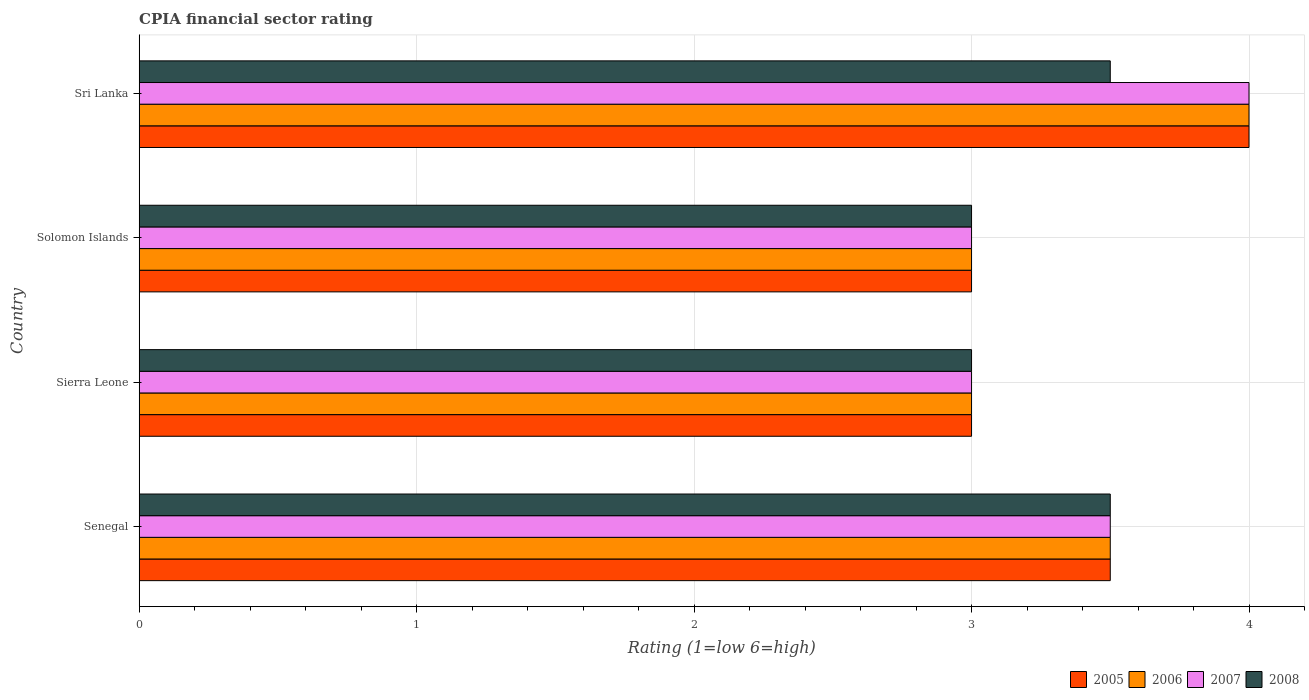How many different coloured bars are there?
Ensure brevity in your answer.  4. Are the number of bars on each tick of the Y-axis equal?
Ensure brevity in your answer.  Yes. How many bars are there on the 3rd tick from the top?
Your answer should be compact. 4. How many bars are there on the 1st tick from the bottom?
Give a very brief answer. 4. What is the label of the 2nd group of bars from the top?
Your answer should be compact. Solomon Islands. What is the CPIA rating in 2005 in Sri Lanka?
Give a very brief answer. 4. In which country was the CPIA rating in 2007 maximum?
Ensure brevity in your answer.  Sri Lanka. In which country was the CPIA rating in 2006 minimum?
Your answer should be compact. Sierra Leone. What is the difference between the CPIA rating in 2007 in Sierra Leone and the CPIA rating in 2005 in Sri Lanka?
Keep it short and to the point. -1. What is the average CPIA rating in 2007 per country?
Keep it short and to the point. 3.38. What is the difference between the CPIA rating in 2007 and CPIA rating in 2008 in Sierra Leone?
Your answer should be very brief. 0. What is the ratio of the CPIA rating in 2008 in Solomon Islands to that in Sri Lanka?
Provide a succinct answer. 0.86. Is the difference between the CPIA rating in 2007 in Solomon Islands and Sri Lanka greater than the difference between the CPIA rating in 2008 in Solomon Islands and Sri Lanka?
Your answer should be compact. No. What is the difference between the highest and the second highest CPIA rating in 2006?
Provide a short and direct response. 0.5. What does the 2nd bar from the bottom in Solomon Islands represents?
Offer a very short reply. 2006. What is the difference between two consecutive major ticks on the X-axis?
Your response must be concise. 1. Are the values on the major ticks of X-axis written in scientific E-notation?
Provide a succinct answer. No. Does the graph contain grids?
Make the answer very short. Yes. How are the legend labels stacked?
Your answer should be compact. Horizontal. What is the title of the graph?
Your answer should be compact. CPIA financial sector rating. Does "2010" appear as one of the legend labels in the graph?
Your response must be concise. No. What is the label or title of the Y-axis?
Provide a succinct answer. Country. What is the Rating (1=low 6=high) in 2005 in Senegal?
Your answer should be compact. 3.5. What is the Rating (1=low 6=high) of 2007 in Senegal?
Provide a short and direct response. 3.5. What is the Rating (1=low 6=high) of 2005 in Sierra Leone?
Make the answer very short. 3. What is the Rating (1=low 6=high) of 2006 in Sierra Leone?
Offer a terse response. 3. What is the Rating (1=low 6=high) in 2006 in Solomon Islands?
Your response must be concise. 3. What is the Rating (1=low 6=high) of 2008 in Solomon Islands?
Provide a succinct answer. 3. What is the Rating (1=low 6=high) of 2006 in Sri Lanka?
Provide a succinct answer. 4. What is the Rating (1=low 6=high) of 2007 in Sri Lanka?
Provide a succinct answer. 4. Across all countries, what is the maximum Rating (1=low 6=high) in 2007?
Ensure brevity in your answer.  4. Across all countries, what is the minimum Rating (1=low 6=high) of 2007?
Provide a short and direct response. 3. Across all countries, what is the minimum Rating (1=low 6=high) in 2008?
Provide a succinct answer. 3. What is the total Rating (1=low 6=high) in 2006 in the graph?
Keep it short and to the point. 13.5. What is the total Rating (1=low 6=high) in 2007 in the graph?
Offer a terse response. 13.5. What is the difference between the Rating (1=low 6=high) of 2005 in Senegal and that in Sierra Leone?
Keep it short and to the point. 0.5. What is the difference between the Rating (1=low 6=high) of 2008 in Senegal and that in Sierra Leone?
Provide a short and direct response. 0.5. What is the difference between the Rating (1=low 6=high) of 2005 in Senegal and that in Sri Lanka?
Provide a succinct answer. -0.5. What is the difference between the Rating (1=low 6=high) of 2006 in Senegal and that in Sri Lanka?
Your answer should be very brief. -0.5. What is the difference between the Rating (1=low 6=high) in 2007 in Senegal and that in Sri Lanka?
Your answer should be compact. -0.5. What is the difference between the Rating (1=low 6=high) in 2008 in Senegal and that in Sri Lanka?
Ensure brevity in your answer.  0. What is the difference between the Rating (1=low 6=high) in 2006 in Sierra Leone and that in Solomon Islands?
Give a very brief answer. 0. What is the difference between the Rating (1=low 6=high) of 2008 in Sierra Leone and that in Solomon Islands?
Ensure brevity in your answer.  0. What is the difference between the Rating (1=low 6=high) in 2006 in Sierra Leone and that in Sri Lanka?
Your response must be concise. -1. What is the difference between the Rating (1=low 6=high) of 2007 in Sierra Leone and that in Sri Lanka?
Make the answer very short. -1. What is the difference between the Rating (1=low 6=high) of 2008 in Sierra Leone and that in Sri Lanka?
Ensure brevity in your answer.  -0.5. What is the difference between the Rating (1=low 6=high) of 2007 in Solomon Islands and that in Sri Lanka?
Make the answer very short. -1. What is the difference between the Rating (1=low 6=high) of 2008 in Solomon Islands and that in Sri Lanka?
Your response must be concise. -0.5. What is the difference between the Rating (1=low 6=high) of 2005 in Senegal and the Rating (1=low 6=high) of 2006 in Sierra Leone?
Keep it short and to the point. 0.5. What is the difference between the Rating (1=low 6=high) in 2006 in Senegal and the Rating (1=low 6=high) in 2007 in Sierra Leone?
Provide a succinct answer. 0.5. What is the difference between the Rating (1=low 6=high) in 2005 in Senegal and the Rating (1=low 6=high) in 2006 in Solomon Islands?
Your answer should be compact. 0.5. What is the difference between the Rating (1=low 6=high) in 2005 in Senegal and the Rating (1=low 6=high) in 2007 in Sri Lanka?
Make the answer very short. -0.5. What is the difference between the Rating (1=low 6=high) in 2006 in Senegal and the Rating (1=low 6=high) in 2008 in Sri Lanka?
Give a very brief answer. 0. What is the difference between the Rating (1=low 6=high) in 2005 in Sierra Leone and the Rating (1=low 6=high) in 2006 in Solomon Islands?
Provide a short and direct response. 0. What is the difference between the Rating (1=low 6=high) in 2005 in Sierra Leone and the Rating (1=low 6=high) in 2008 in Solomon Islands?
Offer a very short reply. 0. What is the difference between the Rating (1=low 6=high) of 2007 in Sierra Leone and the Rating (1=low 6=high) of 2008 in Solomon Islands?
Provide a succinct answer. 0. What is the difference between the Rating (1=low 6=high) in 2005 in Sierra Leone and the Rating (1=low 6=high) in 2006 in Sri Lanka?
Provide a short and direct response. -1. What is the difference between the Rating (1=low 6=high) of 2006 in Sierra Leone and the Rating (1=low 6=high) of 2007 in Sri Lanka?
Provide a succinct answer. -1. What is the difference between the Rating (1=low 6=high) of 2005 in Solomon Islands and the Rating (1=low 6=high) of 2006 in Sri Lanka?
Ensure brevity in your answer.  -1. What is the difference between the Rating (1=low 6=high) of 2005 in Solomon Islands and the Rating (1=low 6=high) of 2008 in Sri Lanka?
Your response must be concise. -0.5. What is the average Rating (1=low 6=high) in 2005 per country?
Keep it short and to the point. 3.38. What is the average Rating (1=low 6=high) of 2006 per country?
Your answer should be compact. 3.38. What is the average Rating (1=low 6=high) of 2007 per country?
Provide a succinct answer. 3.38. What is the difference between the Rating (1=low 6=high) of 2007 and Rating (1=low 6=high) of 2008 in Senegal?
Offer a very short reply. 0. What is the difference between the Rating (1=low 6=high) of 2005 and Rating (1=low 6=high) of 2006 in Sierra Leone?
Make the answer very short. 0. What is the difference between the Rating (1=low 6=high) of 2005 and Rating (1=low 6=high) of 2007 in Sierra Leone?
Provide a short and direct response. 0. What is the difference between the Rating (1=low 6=high) in 2006 and Rating (1=low 6=high) in 2008 in Sierra Leone?
Your answer should be compact. 0. What is the difference between the Rating (1=low 6=high) in 2005 and Rating (1=low 6=high) in 2006 in Solomon Islands?
Keep it short and to the point. 0. What is the difference between the Rating (1=low 6=high) of 2005 and Rating (1=low 6=high) of 2007 in Solomon Islands?
Give a very brief answer. 0. What is the difference between the Rating (1=low 6=high) in 2005 and Rating (1=low 6=high) in 2008 in Solomon Islands?
Provide a succinct answer. 0. What is the difference between the Rating (1=low 6=high) of 2006 and Rating (1=low 6=high) of 2008 in Solomon Islands?
Offer a terse response. 0. What is the difference between the Rating (1=low 6=high) of 2005 and Rating (1=low 6=high) of 2007 in Sri Lanka?
Give a very brief answer. 0. What is the difference between the Rating (1=low 6=high) of 2006 and Rating (1=low 6=high) of 2008 in Sri Lanka?
Keep it short and to the point. 0.5. What is the ratio of the Rating (1=low 6=high) in 2007 in Senegal to that in Sierra Leone?
Ensure brevity in your answer.  1.17. What is the ratio of the Rating (1=low 6=high) in 2006 in Senegal to that in Solomon Islands?
Offer a very short reply. 1.17. What is the ratio of the Rating (1=low 6=high) of 2007 in Senegal to that in Solomon Islands?
Your answer should be very brief. 1.17. What is the ratio of the Rating (1=low 6=high) of 2008 in Senegal to that in Solomon Islands?
Provide a succinct answer. 1.17. What is the ratio of the Rating (1=low 6=high) in 2006 in Senegal to that in Sri Lanka?
Offer a terse response. 0.88. What is the ratio of the Rating (1=low 6=high) in 2007 in Senegal to that in Sri Lanka?
Your response must be concise. 0.88. What is the ratio of the Rating (1=low 6=high) in 2005 in Sierra Leone to that in Solomon Islands?
Your answer should be compact. 1. What is the ratio of the Rating (1=low 6=high) in 2006 in Sierra Leone to that in Solomon Islands?
Your answer should be very brief. 1. What is the ratio of the Rating (1=low 6=high) in 2007 in Sierra Leone to that in Solomon Islands?
Give a very brief answer. 1. What is the ratio of the Rating (1=low 6=high) in 2008 in Sierra Leone to that in Solomon Islands?
Make the answer very short. 1. What is the ratio of the Rating (1=low 6=high) in 2007 in Sierra Leone to that in Sri Lanka?
Offer a very short reply. 0.75. What is the ratio of the Rating (1=low 6=high) of 2008 in Sierra Leone to that in Sri Lanka?
Give a very brief answer. 0.86. What is the ratio of the Rating (1=low 6=high) in 2005 in Solomon Islands to that in Sri Lanka?
Your answer should be very brief. 0.75. What is the ratio of the Rating (1=low 6=high) of 2006 in Solomon Islands to that in Sri Lanka?
Keep it short and to the point. 0.75. What is the ratio of the Rating (1=low 6=high) in 2007 in Solomon Islands to that in Sri Lanka?
Your answer should be very brief. 0.75. What is the difference between the highest and the second highest Rating (1=low 6=high) of 2005?
Provide a short and direct response. 0.5. What is the difference between the highest and the second highest Rating (1=low 6=high) in 2006?
Give a very brief answer. 0.5. What is the difference between the highest and the second highest Rating (1=low 6=high) in 2007?
Offer a very short reply. 0.5. What is the difference between the highest and the lowest Rating (1=low 6=high) in 2006?
Make the answer very short. 1. What is the difference between the highest and the lowest Rating (1=low 6=high) in 2007?
Offer a terse response. 1. 